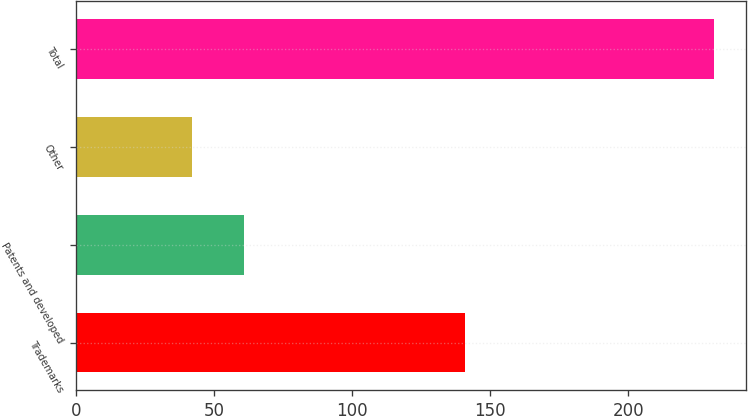<chart> <loc_0><loc_0><loc_500><loc_500><bar_chart><fcel>Trademarks<fcel>Patents and developed<fcel>Other<fcel>Total<nl><fcel>141<fcel>60.9<fcel>42<fcel>231<nl></chart> 